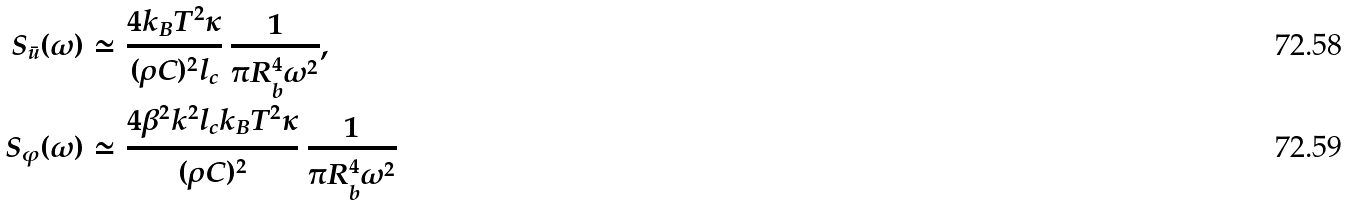Convert formula to latex. <formula><loc_0><loc_0><loc_500><loc_500>S _ { \bar { u } } ( \omega ) & \simeq \frac { 4 k _ { B } T ^ { 2 } \kappa } { ( \rho C ) ^ { 2 } l _ { c } } \, \frac { 1 } { \pi R _ { b } ^ { 4 } \omega ^ { 2 } } , \\ S _ { \varphi } ( \omega ) & \simeq \frac { 4 \beta ^ { 2 } k ^ { 2 } l _ { c } k _ { B } T ^ { 2 } \kappa } { ( \rho C ) ^ { 2 } } \, \frac { 1 } { \pi R _ { b } ^ { 4 } \omega ^ { 2 } }</formula> 